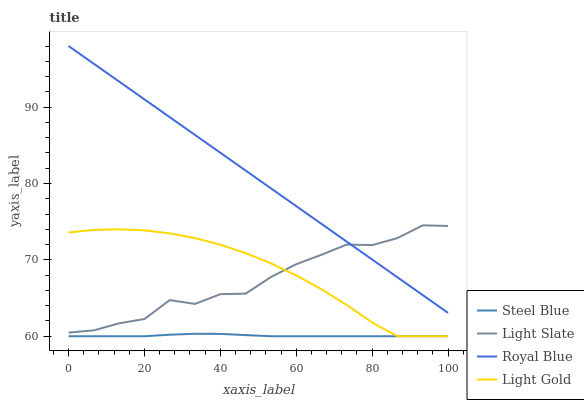Does Steel Blue have the minimum area under the curve?
Answer yes or no. Yes. Does Royal Blue have the maximum area under the curve?
Answer yes or no. Yes. Does Light Gold have the minimum area under the curve?
Answer yes or no. No. Does Light Gold have the maximum area under the curve?
Answer yes or no. No. Is Royal Blue the smoothest?
Answer yes or no. Yes. Is Light Slate the roughest?
Answer yes or no. Yes. Is Light Gold the smoothest?
Answer yes or no. No. Is Light Gold the roughest?
Answer yes or no. No. Does Light Gold have the lowest value?
Answer yes or no. Yes. Does Royal Blue have the lowest value?
Answer yes or no. No. Does Royal Blue have the highest value?
Answer yes or no. Yes. Does Light Gold have the highest value?
Answer yes or no. No. Is Steel Blue less than Royal Blue?
Answer yes or no. Yes. Is Light Slate greater than Steel Blue?
Answer yes or no. Yes. Does Light Gold intersect Light Slate?
Answer yes or no. Yes. Is Light Gold less than Light Slate?
Answer yes or no. No. Is Light Gold greater than Light Slate?
Answer yes or no. No. Does Steel Blue intersect Royal Blue?
Answer yes or no. No. 